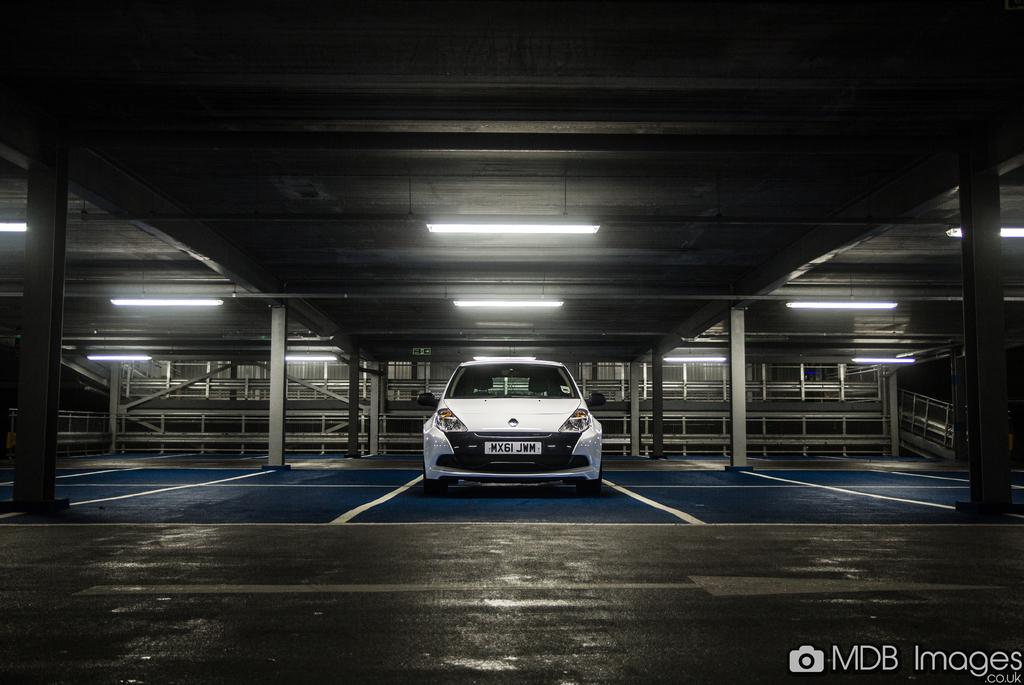What type of object is in the image? There is a vehicle in the image. What color is the vehicle? The vehicle is white in color. Where is the vehicle located? The vehicle is in a parking lot. What feature can be seen at the top of the vehicle? There are lights at the top of the vehicle. What is present at the back of the vehicle? There are metal rods in the back of the vehicle. What color is the trouble in the image? There is no mention of "trouble" in the image; it is a vehicle in a parking lot with lights and metal rods. 